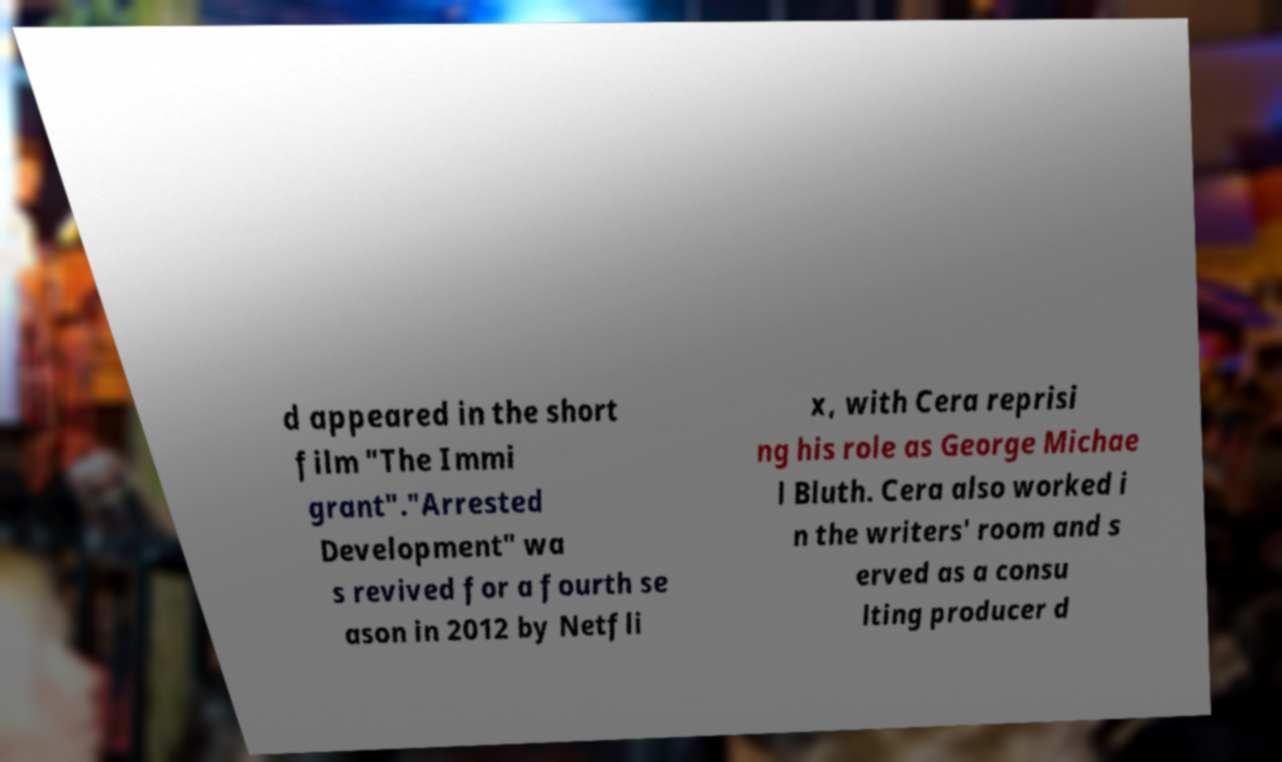What messages or text are displayed in this image? I need them in a readable, typed format. d appeared in the short film "The Immi grant"."Arrested Development" wa s revived for a fourth se ason in 2012 by Netfli x, with Cera reprisi ng his role as George Michae l Bluth. Cera also worked i n the writers' room and s erved as a consu lting producer d 